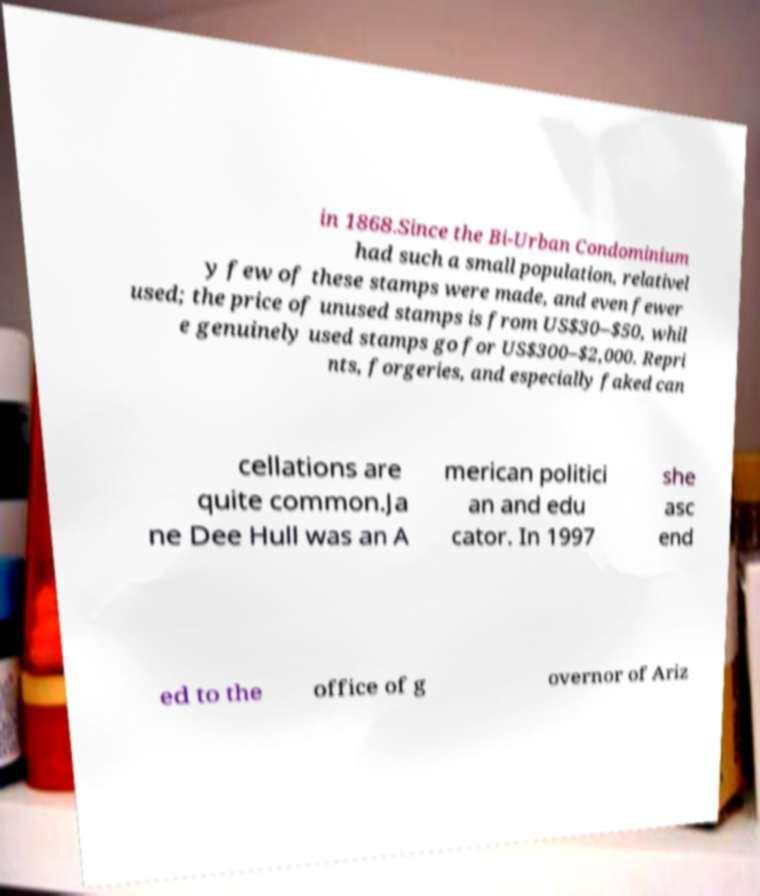For documentation purposes, I need the text within this image transcribed. Could you provide that? in 1868.Since the Bi-Urban Condominium had such a small population, relativel y few of these stamps were made, and even fewer used; the price of unused stamps is from US$30–$50, whil e genuinely used stamps go for US$300–$2,000. Repri nts, forgeries, and especially faked can cellations are quite common.Ja ne Dee Hull was an A merican politici an and edu cator. In 1997 she asc end ed to the office of g overnor of Ariz 